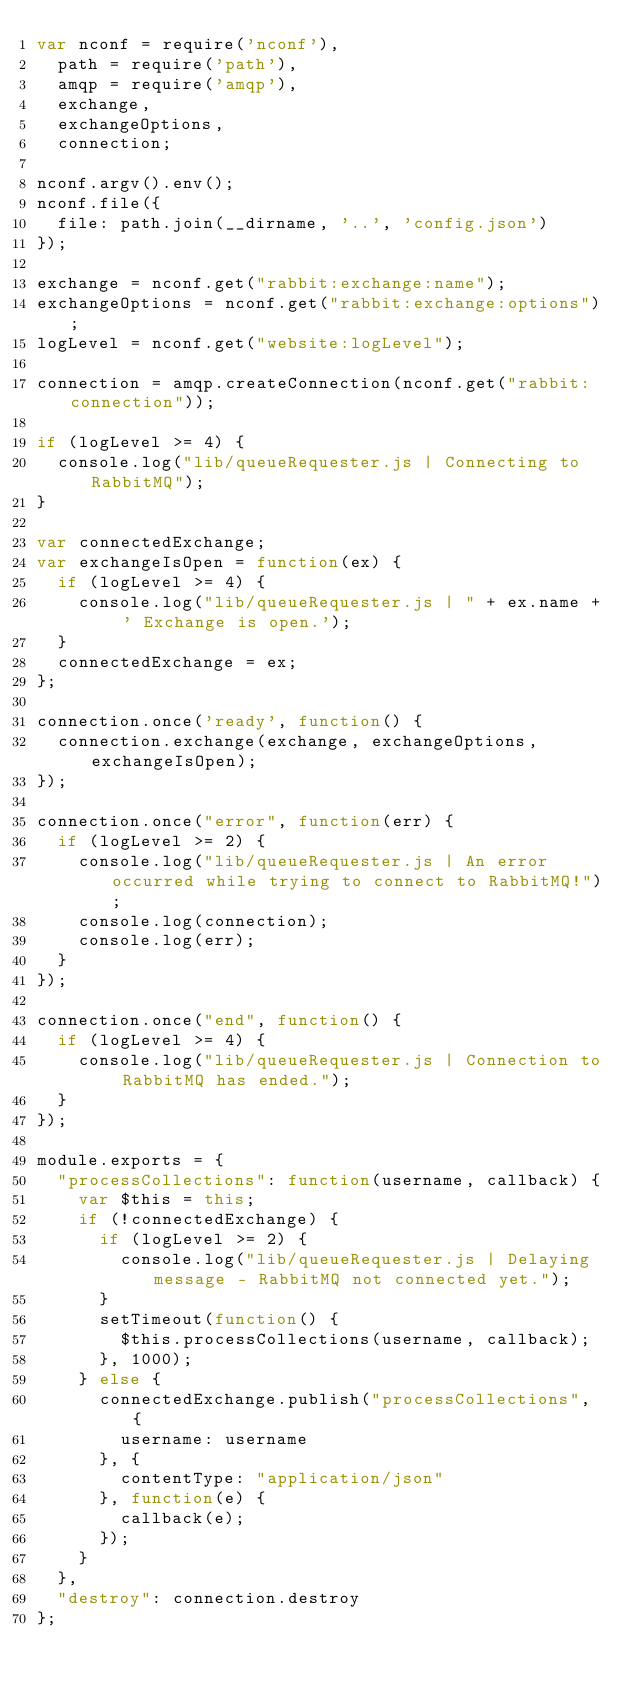<code> <loc_0><loc_0><loc_500><loc_500><_JavaScript_>var nconf = require('nconf'),
  path = require('path'),
  amqp = require('amqp'),
  exchange,
  exchangeOptions,
  connection;

nconf.argv().env();
nconf.file({
  file: path.join(__dirname, '..', 'config.json')
});

exchange = nconf.get("rabbit:exchange:name");
exchangeOptions = nconf.get("rabbit:exchange:options");
logLevel = nconf.get("website:logLevel");

connection = amqp.createConnection(nconf.get("rabbit:connection"));

if (logLevel >= 4) {
  console.log("lib/queueRequester.js | Connecting to RabbitMQ");
}

var connectedExchange;
var exchangeIsOpen = function(ex) {
  if (logLevel >= 4) {
    console.log("lib/queueRequester.js | " + ex.name + ' Exchange is open.');
  }
  connectedExchange = ex;
};

connection.once('ready', function() {
  connection.exchange(exchange, exchangeOptions, exchangeIsOpen);
});

connection.once("error", function(err) {
  if (logLevel >= 2) {
    console.log("lib/queueRequester.js | An error occurred while trying to connect to RabbitMQ!");
    console.log(connection);
    console.log(err);
  }
});

connection.once("end", function() {
  if (logLevel >= 4) {
    console.log("lib/queueRequester.js | Connection to RabbitMQ has ended.");
  }
});

module.exports = {
  "processCollections": function(username, callback) {
    var $this = this;
    if (!connectedExchange) {
      if (logLevel >= 2) {
        console.log("lib/queueRequester.js | Delaying message - RabbitMQ not connected yet.");
      }
      setTimeout(function() {
        $this.processCollections(username, callback);
      }, 1000);
    } else {
      connectedExchange.publish("processCollections", {
        username: username
      }, {
        contentType: "application/json"
      }, function(e) {
        callback(e);
      });
    }
  },
  "destroy": connection.destroy
};
</code> 